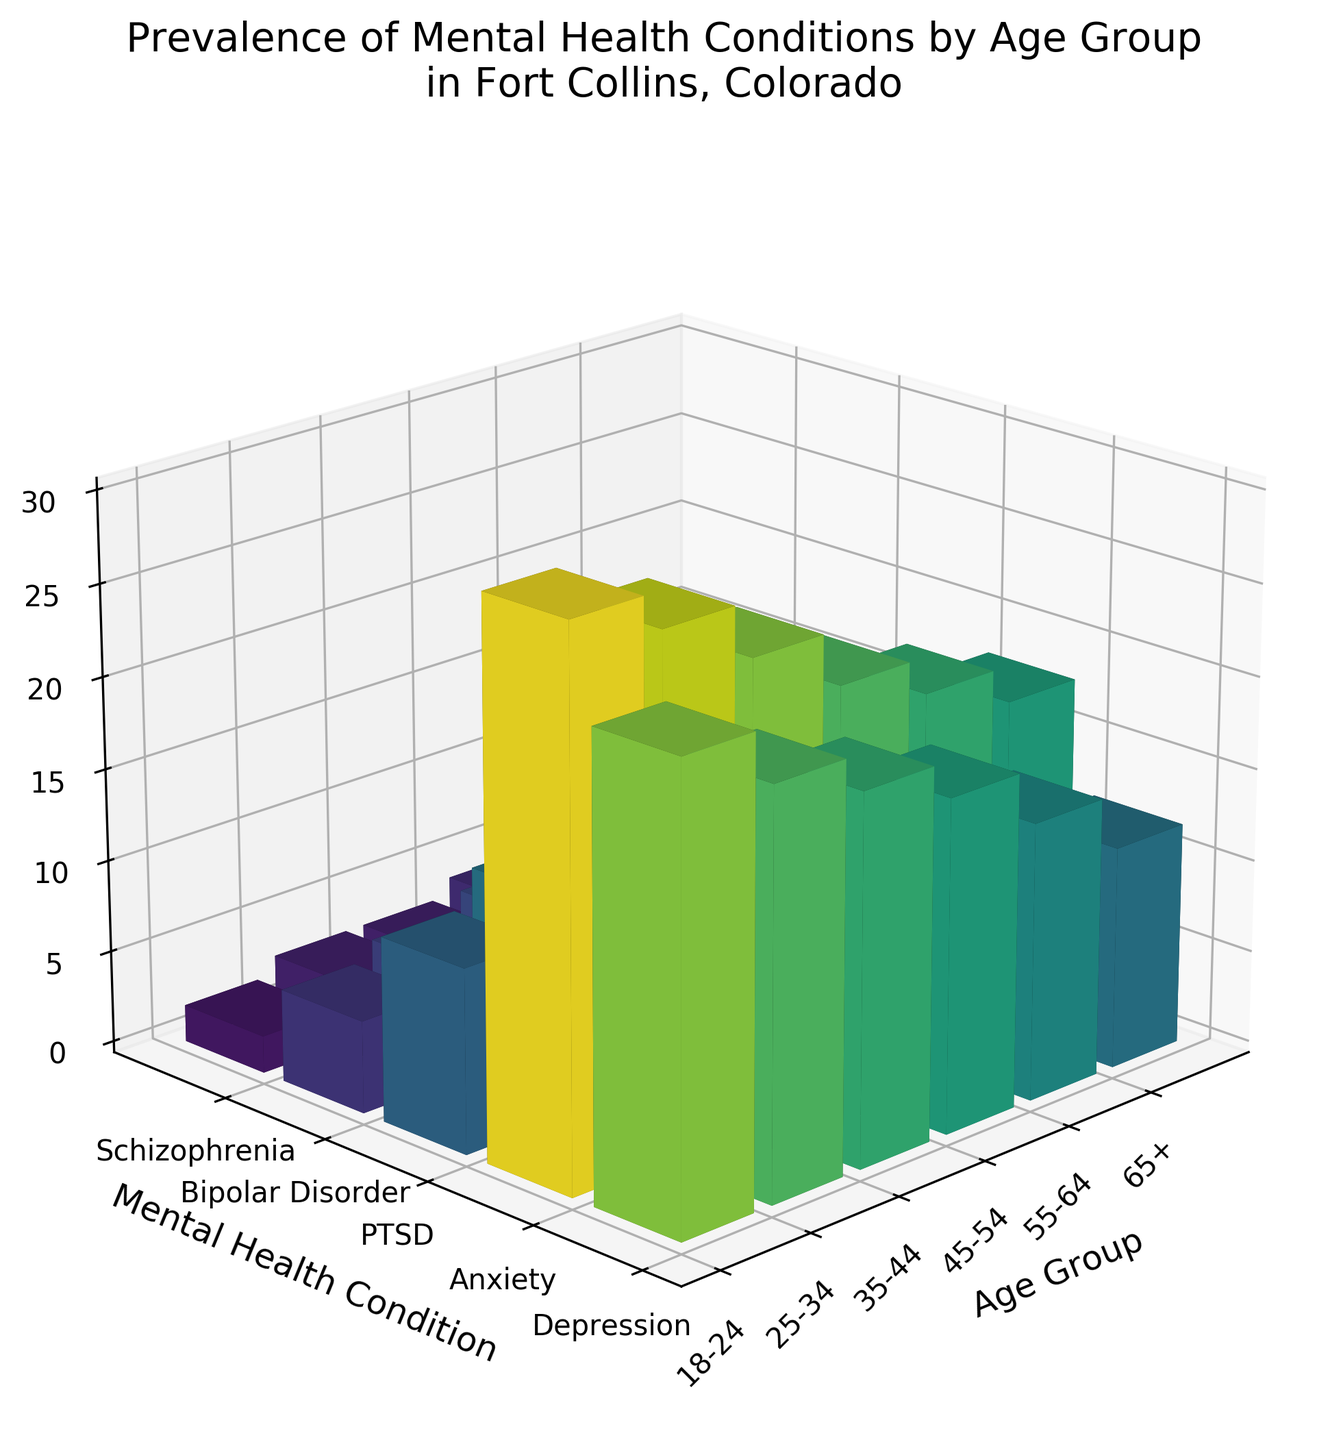Which age group has the highest prevalence of depression? By observing the height of the columns labeled "Depression" for each age group, the tallest column corresponds to the 18-24 age group.
Answer: 18-24 What is the total prevalence of mental health conditions for the 25-34 age group? Sum the prevalence percentages of Depression (22), Anxiety (28), PTSD (12), Bipolar Disorder (6), and Schizophrenia (3) for the 25-34 age group: 22 + 28 + 12 + 6 + 3.
Answer: 71 How does the prevalence of bipolar disorder compare between the 45-54 and 55-64 age groups? Compare the heights of the columns labeled "Bipolar Disorder" for the 45-54 and 55-64 age groups; they are both approximately the same height, with 45-54 at 8% and 55-64 at 7%.
Answer: Similar, with 45-54 slightly higher Which mental health condition has the most consistent prevalence across all age groups? By comparing the heights of the columns for each mental health condition across all age groups, Schizophrenia shows the least variation.
Answer: Schizophrenia What is the difference in prevalence of anxiety between the 18-24 and 65+ age groups? Subtract the prevalence of Anxiety in the 65+ age group (18%) from that in the 18-24 age group (30%): 30 - 18.
Answer: 12% Which mental health condition has the highest peak prevalence across any age group, and what is the value? Scan all columns for the tallest among any mental health condition across age groups. The highest is Anxiety in the 18-24 age group, with a value of 30%.
Answer: Anxiety, 30% How does the prevalence of PTSD change from the 18-24 to 45-54 age groups? Observe the heights of the "PTSD" columns from 18-24 to 45-54; the values increase from 10% to 14% then peak at 15% at 35-44 before slightly decreasing.
Answer: Increases, with a peak then slight decrease What is the average prevalence of mental health conditions for the 35-44 age group? Add the prevalence percentages for the 35-44 age group: Depression (20), Anxiety (25), PTSD (15), Bipolar Disorder (7), Schizophrenia (3) and divide by 5: (20+25+15+7+3)/5.
Answer: 14% Is the prevalence of schizophrenia higher in the 25-34 age group or the 65+ age group? Compare the heights of the columns labeled "Schizophrenia" for the 25-34 (3%) and 65+ (2%) age groups.
Answer: 25-34 Which age group shows the lowest overall prevalence of mental health conditions? Sum the prevalence percentages for each age group and identify the lowest total. The 65+ group has the lowest total: 12 (Depression) + 18 (Anxiety) + 8 (PTSD) + 5 (Bipolar Disorder) + 2 (Schizophrenia).
Answer: 65+ 